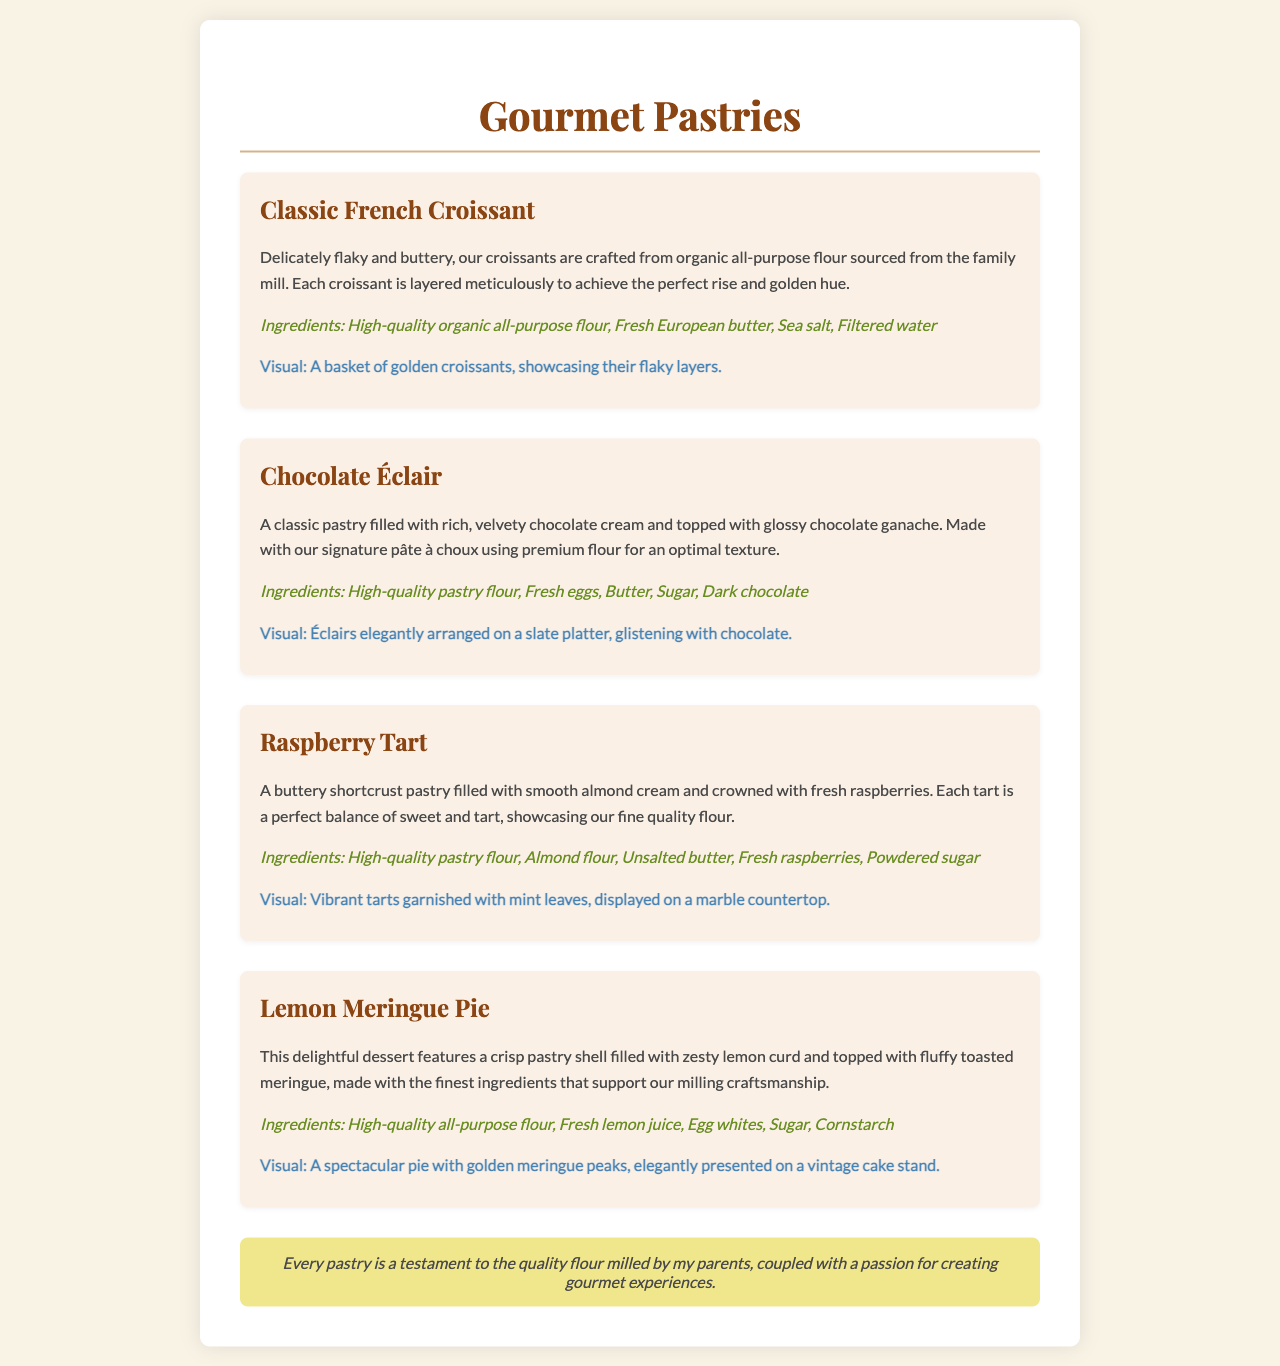What is the main highlight of the menu? The main highlight of the menu is exquisite pastries.
Answer: exquisite pastries What ingredients are used in the Classic French Croissant? The ingredients listed for the Classic French Croissant include organic all-purpose flour, fresh European butter, sea salt, and filtered water.
Answer: High-quality organic all-purpose flour, Fresh European butter, Sea salt, Filtered water How are the Chocolate Éclairs displayed in the visual description? The visual description states that Éclairs are elegantly arranged on a slate platter, glistening with chocolate.
Answer: elegantly arranged on a slate platter What type of filling does the Raspberry Tart contain? The Raspberry Tart is filled with smooth almond cream.
Answer: smooth almond cream Which pastry features a toasted meringue topping? The pastry that features a toasted meringue topping is the Lemon Meringue Pie.
Answer: Lemon Meringue Pie How is the pastry quality supported in the document? The document mentions that every pastry is a testament to the quality flour milled by the author's parents.
Answer: quality flour milled by my parents What display is suggested for the Raspberry Tart? The suggested display for the Raspberry Tart includes vibrant tarts garnished with mint leaves on a marble countertop.
Answer: garnished with mint leaves, displayed on a marble countertop What type of pastry is made using pâte à choux? The type of pastry made using pâte à choux is the Chocolate Éclair.
Answer: Chocolate Éclair 